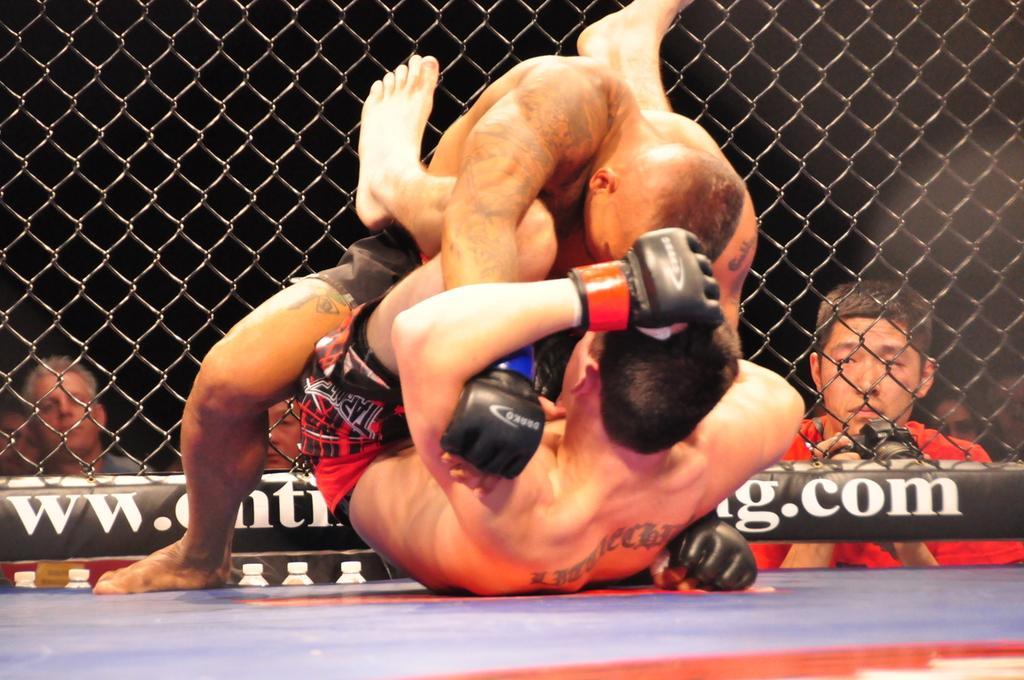What event is taking place in the image? The image is taken during a wrestling match. What are the two men in the center of the picture doing? They are fighting in the center of the picture. What can be seen in the background of the image? There are people and fencing in the background of the image. What religious beliefs do the two men fighting in the image share? There is no information about the religious beliefs of the two men fighting in the image. 